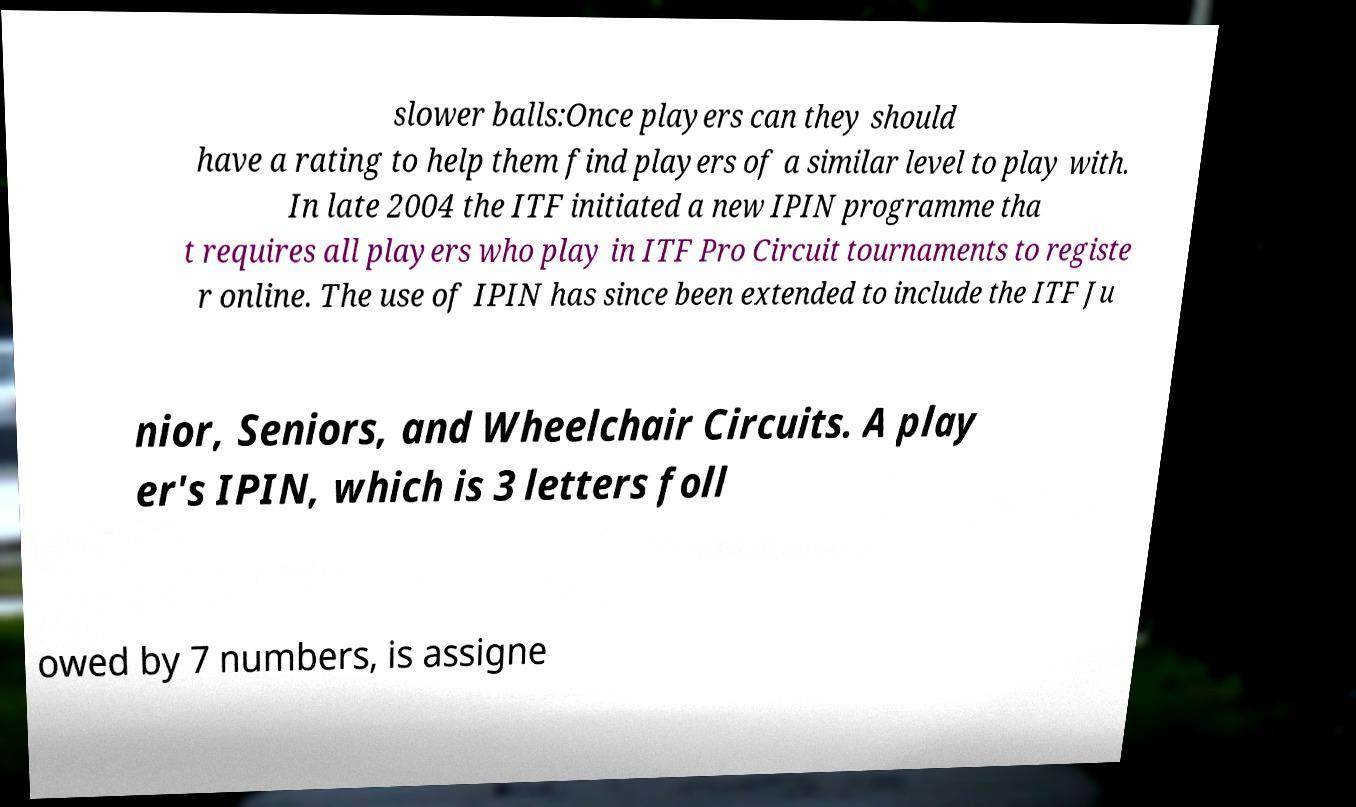There's text embedded in this image that I need extracted. Can you transcribe it verbatim? slower balls:Once players can they should have a rating to help them find players of a similar level to play with. In late 2004 the ITF initiated a new IPIN programme tha t requires all players who play in ITF Pro Circuit tournaments to registe r online. The use of IPIN has since been extended to include the ITF Ju nior, Seniors, and Wheelchair Circuits. A play er's IPIN, which is 3 letters foll owed by 7 numbers, is assigne 